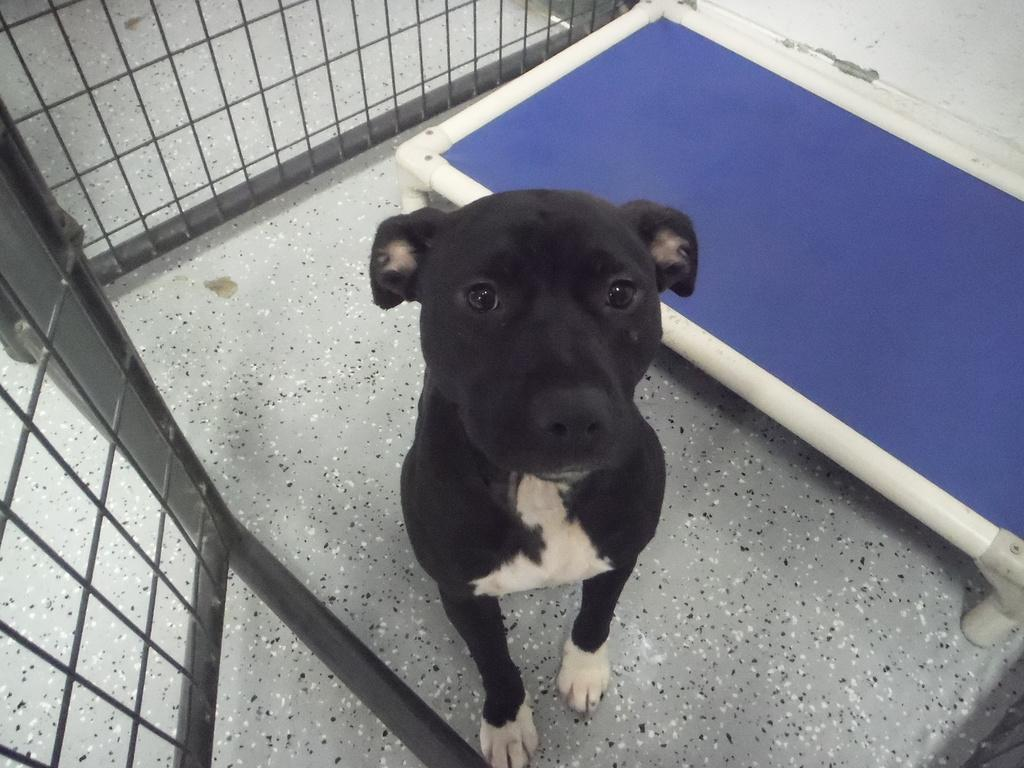What type of animal is in the image? There is a dog in the image. Where is the dog located in the image? The dog is sitting on the floor. What structure can be seen in the image? There is an iron gate in the image. What piece of furniture is present in the image? There is a table in the image. What arithmetic problem is the dog solving in the image? There is no arithmetic problem present in the image, as it features a dog sitting on the floor and other elements like an iron gate and a table. 